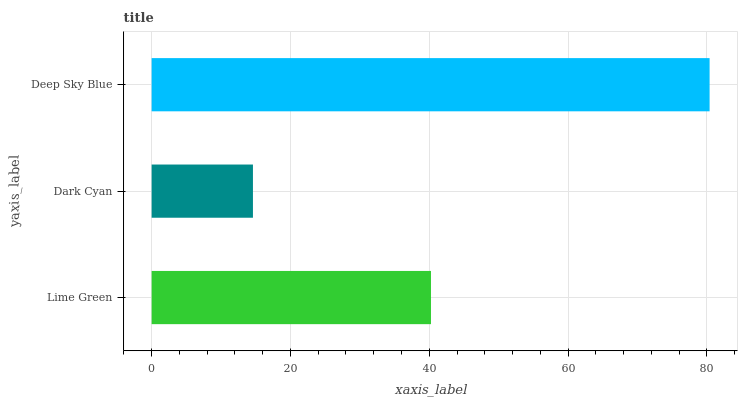Is Dark Cyan the minimum?
Answer yes or no. Yes. Is Deep Sky Blue the maximum?
Answer yes or no. Yes. Is Deep Sky Blue the minimum?
Answer yes or no. No. Is Dark Cyan the maximum?
Answer yes or no. No. Is Deep Sky Blue greater than Dark Cyan?
Answer yes or no. Yes. Is Dark Cyan less than Deep Sky Blue?
Answer yes or no. Yes. Is Dark Cyan greater than Deep Sky Blue?
Answer yes or no. No. Is Deep Sky Blue less than Dark Cyan?
Answer yes or no. No. Is Lime Green the high median?
Answer yes or no. Yes. Is Lime Green the low median?
Answer yes or no. Yes. Is Deep Sky Blue the high median?
Answer yes or no. No. Is Deep Sky Blue the low median?
Answer yes or no. No. 